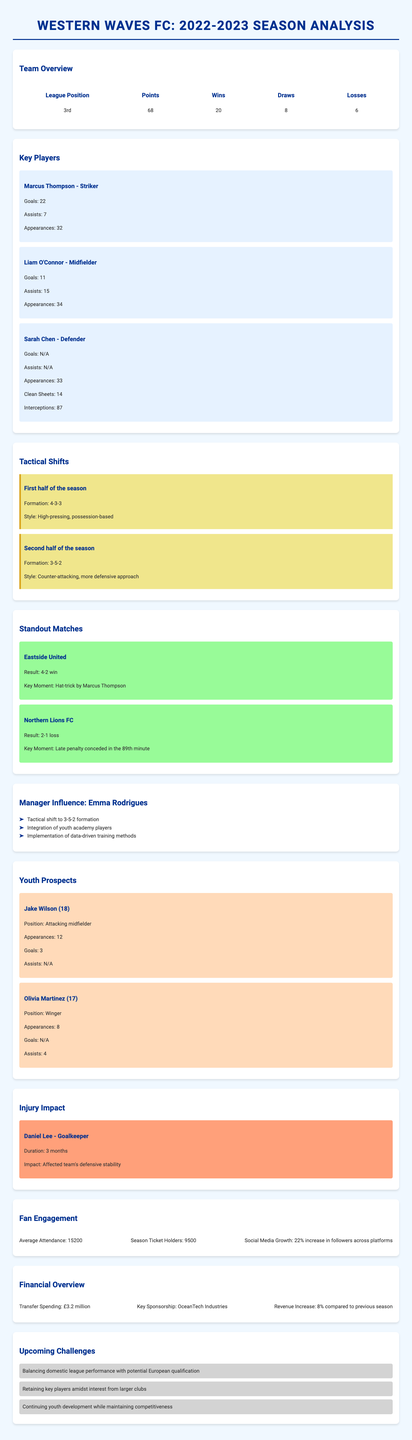What was the final league position of Western Waves FC? The final league position is stated in the team overview section of the document.
Answer: 3rd Who was the top goal scorer for Western Waves FC? The top goal scorer is mentioned under the key players section, highlighting their goal statistics.
Answer: Marcus Thompson What formation did Western Waves FC use in the second half of the season? The formation used in the second half is detailed in the tactical shifts section of the document.
Answer: 3-5-2 How many assists did Liam O'Connor have during the season? The number of assists by Liam O'Connor is provided in his player statistics.
Answer: 15 What was the key challenge mentioned for the upcoming season? The document lists several challenges, requiring fans to identify one mentioned specifically.
Answer: Balancing domestic league performance with potential European qualification Which match featured a hat-trick by a player? The standout matches section details a specific match with a notable individual performance.
Answer: Eastside United What percentage increase did the social media followers experience? The growth in social media followers is specified in the fan engagement section of the document.
Answer: 22% How many average attendees did Western Waves FC have during the season? Average attendance figures are noted in the fan engagement section.
Answer: 15,200 What injury impacted the team's defensive stability? The injury impact section mentions a player whose absence affected the team's defense.
Answer: Daniel Lee 